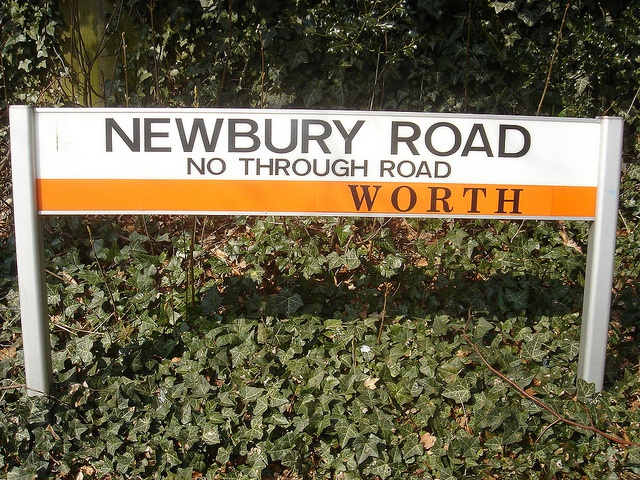Describe the objects in this image and their specific colors. I can see various objects in this image with different colors. 